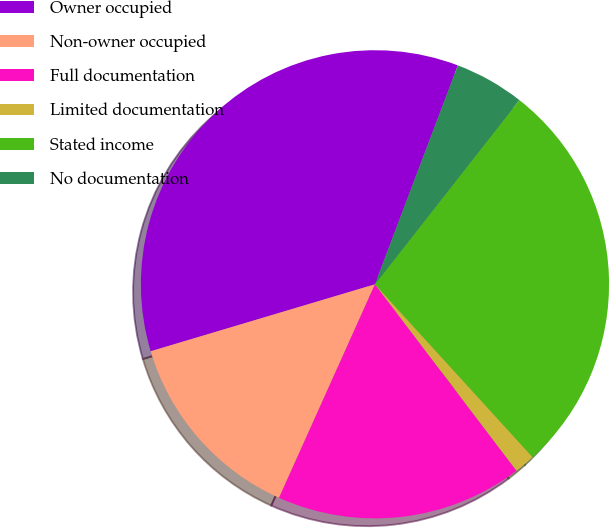<chart> <loc_0><loc_0><loc_500><loc_500><pie_chart><fcel>Owner occupied<fcel>Non-owner occupied<fcel>Full documentation<fcel>Limited documentation<fcel>Stated income<fcel>No documentation<nl><fcel>35.38%<fcel>13.66%<fcel>17.06%<fcel>1.43%<fcel>27.65%<fcel>4.82%<nl></chart> 